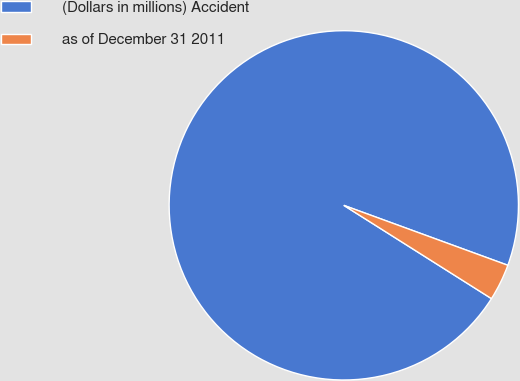Convert chart. <chart><loc_0><loc_0><loc_500><loc_500><pie_chart><fcel>(Dollars in millions) Accident<fcel>as of December 31 2011<nl><fcel>96.61%<fcel>3.39%<nl></chart> 